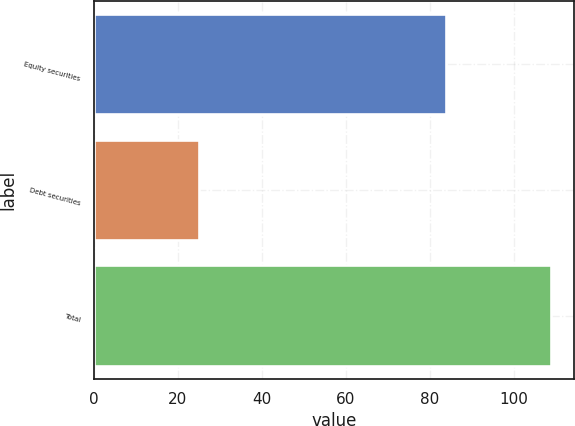Convert chart to OTSL. <chart><loc_0><loc_0><loc_500><loc_500><bar_chart><fcel>Equity securities<fcel>Debt securities<fcel>Total<nl><fcel>84<fcel>25<fcel>109<nl></chart> 